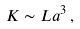<formula> <loc_0><loc_0><loc_500><loc_500>K \sim L a ^ { 3 } \, ,</formula> 